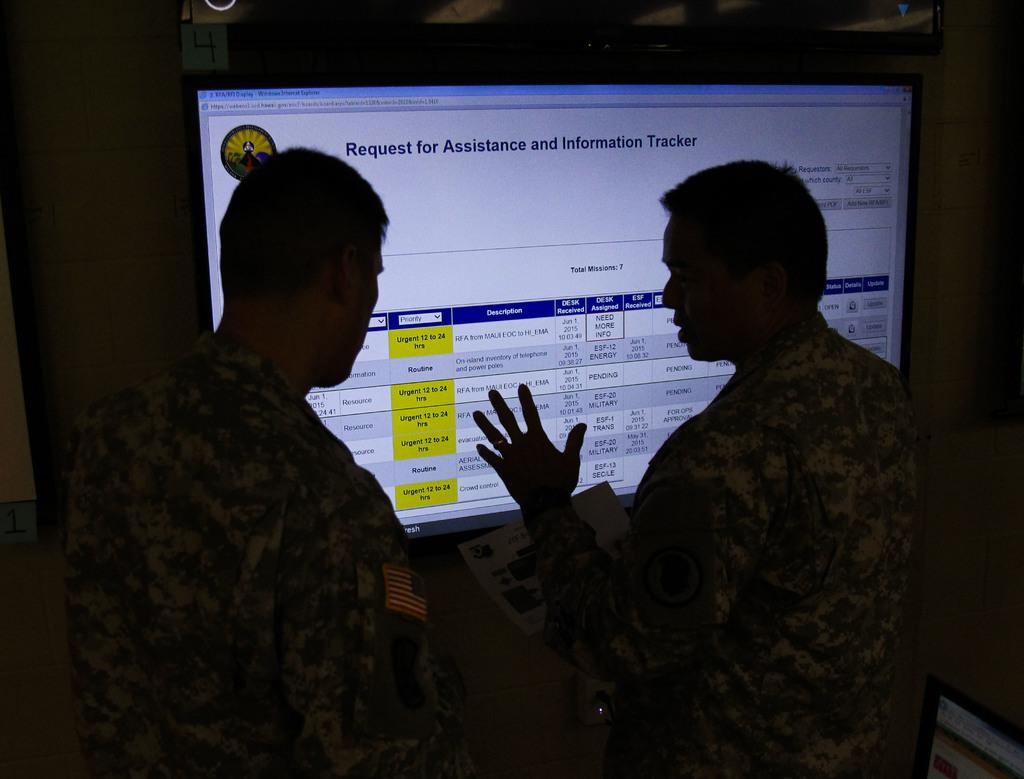How many people are in the image? There are two people in the image. What are the people doing in the image? The people are standing and facing towards the back. What is in front of the people? There is a screen in front of them. What can be seen on the screen? The screen displays some text. What is the color of the background in the image? The background of the image is black. What type of crate is being carried by the people in the image? There is no crate present in the image; the people are standing and facing towards the back with a screen in front of them. 